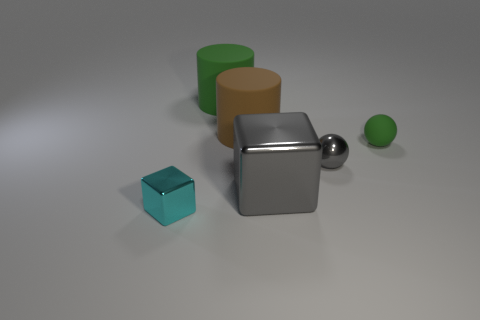Add 2 cyan objects. How many objects exist? 8 Subtract all blocks. How many objects are left? 4 Add 6 green matte objects. How many green matte objects exist? 8 Subtract 0 red cylinders. How many objects are left? 6 Subtract all matte cylinders. Subtract all gray metal cubes. How many objects are left? 3 Add 5 big gray objects. How many big gray objects are left? 6 